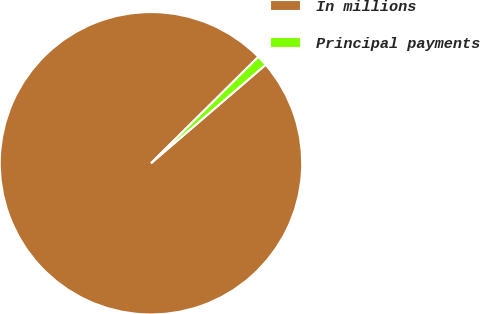<chart> <loc_0><loc_0><loc_500><loc_500><pie_chart><fcel>In millions<fcel>Principal payments<nl><fcel>98.87%<fcel>1.13%<nl></chart> 